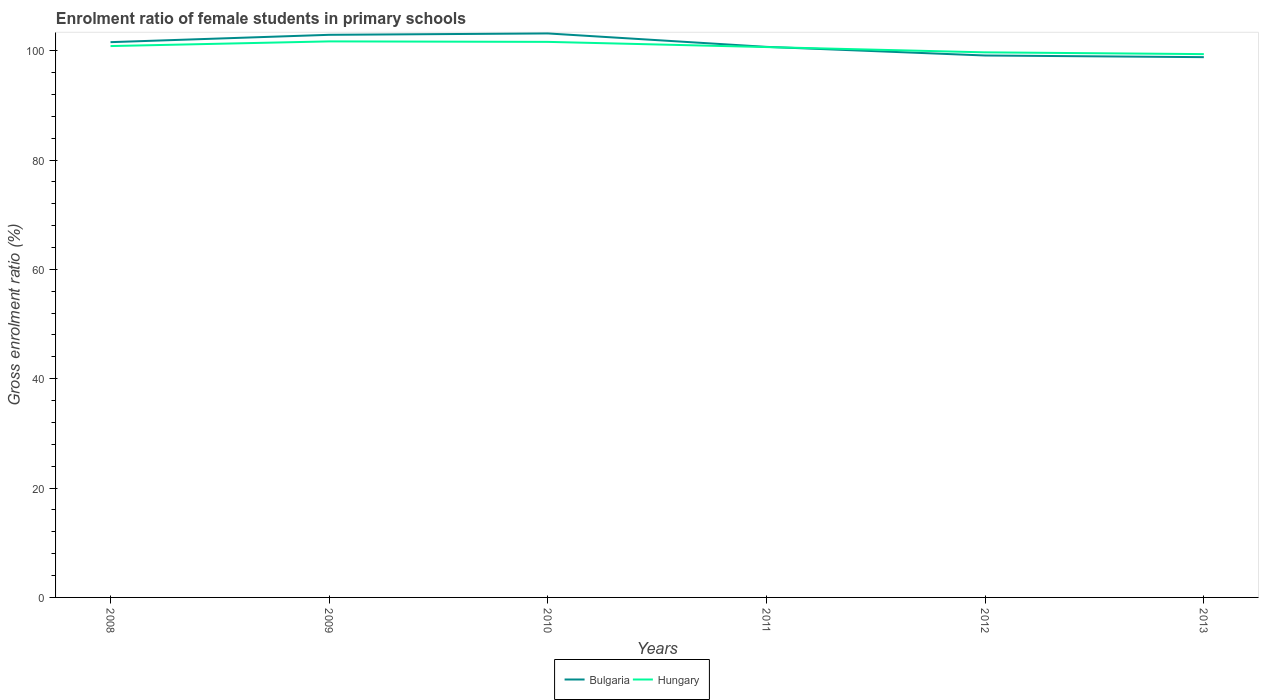Does the line corresponding to Hungary intersect with the line corresponding to Bulgaria?
Ensure brevity in your answer.  Yes. Across all years, what is the maximum enrolment ratio of female students in primary schools in Hungary?
Keep it short and to the point. 99.37. What is the total enrolment ratio of female students in primary schools in Bulgaria in the graph?
Make the answer very short. 2.44. What is the difference between the highest and the second highest enrolment ratio of female students in primary schools in Hungary?
Your answer should be compact. 2.33. What is the difference between the highest and the lowest enrolment ratio of female students in primary schools in Bulgaria?
Provide a short and direct response. 3. Is the enrolment ratio of female students in primary schools in Hungary strictly greater than the enrolment ratio of female students in primary schools in Bulgaria over the years?
Provide a short and direct response. No. How many years are there in the graph?
Give a very brief answer. 6. What is the difference between two consecutive major ticks on the Y-axis?
Make the answer very short. 20. Are the values on the major ticks of Y-axis written in scientific E-notation?
Give a very brief answer. No. What is the title of the graph?
Give a very brief answer. Enrolment ratio of female students in primary schools. Does "Kiribati" appear as one of the legend labels in the graph?
Your answer should be very brief. No. What is the label or title of the Y-axis?
Make the answer very short. Gross enrolment ratio (%). What is the Gross enrolment ratio (%) of Bulgaria in 2008?
Give a very brief answer. 101.55. What is the Gross enrolment ratio (%) of Hungary in 2008?
Provide a short and direct response. 100.84. What is the Gross enrolment ratio (%) of Bulgaria in 2009?
Keep it short and to the point. 102.9. What is the Gross enrolment ratio (%) of Hungary in 2009?
Give a very brief answer. 101.69. What is the Gross enrolment ratio (%) of Bulgaria in 2010?
Offer a terse response. 103.15. What is the Gross enrolment ratio (%) of Hungary in 2010?
Your answer should be very brief. 101.6. What is the Gross enrolment ratio (%) in Bulgaria in 2011?
Your response must be concise. 100.69. What is the Gross enrolment ratio (%) of Hungary in 2011?
Ensure brevity in your answer.  100.66. What is the Gross enrolment ratio (%) in Bulgaria in 2012?
Your response must be concise. 99.11. What is the Gross enrolment ratio (%) of Hungary in 2012?
Offer a terse response. 99.69. What is the Gross enrolment ratio (%) in Bulgaria in 2013?
Your answer should be compact. 98.81. What is the Gross enrolment ratio (%) of Hungary in 2013?
Provide a succinct answer. 99.37. Across all years, what is the maximum Gross enrolment ratio (%) in Bulgaria?
Give a very brief answer. 103.15. Across all years, what is the maximum Gross enrolment ratio (%) in Hungary?
Provide a succinct answer. 101.69. Across all years, what is the minimum Gross enrolment ratio (%) of Bulgaria?
Offer a terse response. 98.81. Across all years, what is the minimum Gross enrolment ratio (%) in Hungary?
Give a very brief answer. 99.37. What is the total Gross enrolment ratio (%) in Bulgaria in the graph?
Provide a succinct answer. 606.21. What is the total Gross enrolment ratio (%) of Hungary in the graph?
Make the answer very short. 603.84. What is the difference between the Gross enrolment ratio (%) of Bulgaria in 2008 and that in 2009?
Give a very brief answer. -1.34. What is the difference between the Gross enrolment ratio (%) in Hungary in 2008 and that in 2009?
Provide a short and direct response. -0.85. What is the difference between the Gross enrolment ratio (%) of Bulgaria in 2008 and that in 2010?
Offer a terse response. -1.59. What is the difference between the Gross enrolment ratio (%) of Hungary in 2008 and that in 2010?
Provide a succinct answer. -0.76. What is the difference between the Gross enrolment ratio (%) of Bulgaria in 2008 and that in 2011?
Ensure brevity in your answer.  0.86. What is the difference between the Gross enrolment ratio (%) in Hungary in 2008 and that in 2011?
Keep it short and to the point. 0.18. What is the difference between the Gross enrolment ratio (%) of Bulgaria in 2008 and that in 2012?
Your response must be concise. 2.44. What is the difference between the Gross enrolment ratio (%) of Hungary in 2008 and that in 2012?
Your answer should be very brief. 1.15. What is the difference between the Gross enrolment ratio (%) in Bulgaria in 2008 and that in 2013?
Offer a very short reply. 2.74. What is the difference between the Gross enrolment ratio (%) of Hungary in 2008 and that in 2013?
Keep it short and to the point. 1.47. What is the difference between the Gross enrolment ratio (%) in Bulgaria in 2009 and that in 2010?
Your answer should be very brief. -0.25. What is the difference between the Gross enrolment ratio (%) in Hungary in 2009 and that in 2010?
Offer a terse response. 0.09. What is the difference between the Gross enrolment ratio (%) of Bulgaria in 2009 and that in 2011?
Your answer should be compact. 2.2. What is the difference between the Gross enrolment ratio (%) in Hungary in 2009 and that in 2011?
Your answer should be compact. 1.04. What is the difference between the Gross enrolment ratio (%) of Bulgaria in 2009 and that in 2012?
Offer a very short reply. 3.78. What is the difference between the Gross enrolment ratio (%) of Hungary in 2009 and that in 2012?
Make the answer very short. 2. What is the difference between the Gross enrolment ratio (%) of Bulgaria in 2009 and that in 2013?
Offer a terse response. 4.08. What is the difference between the Gross enrolment ratio (%) in Hungary in 2009 and that in 2013?
Your response must be concise. 2.33. What is the difference between the Gross enrolment ratio (%) of Bulgaria in 2010 and that in 2011?
Provide a short and direct response. 2.46. What is the difference between the Gross enrolment ratio (%) of Hungary in 2010 and that in 2011?
Offer a very short reply. 0.95. What is the difference between the Gross enrolment ratio (%) in Bulgaria in 2010 and that in 2012?
Keep it short and to the point. 4.04. What is the difference between the Gross enrolment ratio (%) in Hungary in 2010 and that in 2012?
Provide a short and direct response. 1.92. What is the difference between the Gross enrolment ratio (%) of Bulgaria in 2010 and that in 2013?
Your answer should be very brief. 4.34. What is the difference between the Gross enrolment ratio (%) in Hungary in 2010 and that in 2013?
Make the answer very short. 2.24. What is the difference between the Gross enrolment ratio (%) in Bulgaria in 2011 and that in 2012?
Your response must be concise. 1.58. What is the difference between the Gross enrolment ratio (%) in Hungary in 2011 and that in 2012?
Provide a short and direct response. 0.97. What is the difference between the Gross enrolment ratio (%) in Bulgaria in 2011 and that in 2013?
Make the answer very short. 1.88. What is the difference between the Gross enrolment ratio (%) of Hungary in 2011 and that in 2013?
Your answer should be compact. 1.29. What is the difference between the Gross enrolment ratio (%) in Bulgaria in 2012 and that in 2013?
Keep it short and to the point. 0.3. What is the difference between the Gross enrolment ratio (%) in Hungary in 2012 and that in 2013?
Provide a succinct answer. 0.32. What is the difference between the Gross enrolment ratio (%) in Bulgaria in 2008 and the Gross enrolment ratio (%) in Hungary in 2009?
Provide a short and direct response. -0.14. What is the difference between the Gross enrolment ratio (%) in Bulgaria in 2008 and the Gross enrolment ratio (%) in Hungary in 2010?
Give a very brief answer. -0.05. What is the difference between the Gross enrolment ratio (%) of Bulgaria in 2008 and the Gross enrolment ratio (%) of Hungary in 2011?
Keep it short and to the point. 0.9. What is the difference between the Gross enrolment ratio (%) of Bulgaria in 2008 and the Gross enrolment ratio (%) of Hungary in 2012?
Offer a very short reply. 1.87. What is the difference between the Gross enrolment ratio (%) in Bulgaria in 2008 and the Gross enrolment ratio (%) in Hungary in 2013?
Ensure brevity in your answer.  2.19. What is the difference between the Gross enrolment ratio (%) of Bulgaria in 2009 and the Gross enrolment ratio (%) of Hungary in 2010?
Offer a terse response. 1.29. What is the difference between the Gross enrolment ratio (%) of Bulgaria in 2009 and the Gross enrolment ratio (%) of Hungary in 2011?
Make the answer very short. 2.24. What is the difference between the Gross enrolment ratio (%) in Bulgaria in 2009 and the Gross enrolment ratio (%) in Hungary in 2012?
Provide a succinct answer. 3.21. What is the difference between the Gross enrolment ratio (%) in Bulgaria in 2009 and the Gross enrolment ratio (%) in Hungary in 2013?
Your answer should be very brief. 3.53. What is the difference between the Gross enrolment ratio (%) of Bulgaria in 2010 and the Gross enrolment ratio (%) of Hungary in 2011?
Your answer should be very brief. 2.49. What is the difference between the Gross enrolment ratio (%) in Bulgaria in 2010 and the Gross enrolment ratio (%) in Hungary in 2012?
Your answer should be compact. 3.46. What is the difference between the Gross enrolment ratio (%) of Bulgaria in 2010 and the Gross enrolment ratio (%) of Hungary in 2013?
Your answer should be compact. 3.78. What is the difference between the Gross enrolment ratio (%) of Bulgaria in 2011 and the Gross enrolment ratio (%) of Hungary in 2013?
Offer a very short reply. 1.33. What is the difference between the Gross enrolment ratio (%) of Bulgaria in 2012 and the Gross enrolment ratio (%) of Hungary in 2013?
Ensure brevity in your answer.  -0.25. What is the average Gross enrolment ratio (%) of Bulgaria per year?
Give a very brief answer. 101.03. What is the average Gross enrolment ratio (%) of Hungary per year?
Your answer should be compact. 100.64. In the year 2008, what is the difference between the Gross enrolment ratio (%) of Bulgaria and Gross enrolment ratio (%) of Hungary?
Your answer should be compact. 0.71. In the year 2009, what is the difference between the Gross enrolment ratio (%) in Bulgaria and Gross enrolment ratio (%) in Hungary?
Your answer should be very brief. 1.2. In the year 2010, what is the difference between the Gross enrolment ratio (%) of Bulgaria and Gross enrolment ratio (%) of Hungary?
Give a very brief answer. 1.54. In the year 2011, what is the difference between the Gross enrolment ratio (%) in Bulgaria and Gross enrolment ratio (%) in Hungary?
Your response must be concise. 0.03. In the year 2012, what is the difference between the Gross enrolment ratio (%) of Bulgaria and Gross enrolment ratio (%) of Hungary?
Your response must be concise. -0.58. In the year 2013, what is the difference between the Gross enrolment ratio (%) in Bulgaria and Gross enrolment ratio (%) in Hungary?
Your response must be concise. -0.55. What is the ratio of the Gross enrolment ratio (%) of Hungary in 2008 to that in 2009?
Give a very brief answer. 0.99. What is the ratio of the Gross enrolment ratio (%) of Bulgaria in 2008 to that in 2010?
Your answer should be compact. 0.98. What is the ratio of the Gross enrolment ratio (%) of Hungary in 2008 to that in 2010?
Give a very brief answer. 0.99. What is the ratio of the Gross enrolment ratio (%) in Bulgaria in 2008 to that in 2011?
Provide a succinct answer. 1.01. What is the ratio of the Gross enrolment ratio (%) of Hungary in 2008 to that in 2011?
Your answer should be compact. 1. What is the ratio of the Gross enrolment ratio (%) of Bulgaria in 2008 to that in 2012?
Your response must be concise. 1.02. What is the ratio of the Gross enrolment ratio (%) in Hungary in 2008 to that in 2012?
Provide a succinct answer. 1.01. What is the ratio of the Gross enrolment ratio (%) in Bulgaria in 2008 to that in 2013?
Provide a succinct answer. 1.03. What is the ratio of the Gross enrolment ratio (%) in Hungary in 2008 to that in 2013?
Offer a very short reply. 1.01. What is the ratio of the Gross enrolment ratio (%) in Bulgaria in 2009 to that in 2011?
Keep it short and to the point. 1.02. What is the ratio of the Gross enrolment ratio (%) of Hungary in 2009 to that in 2011?
Give a very brief answer. 1.01. What is the ratio of the Gross enrolment ratio (%) in Bulgaria in 2009 to that in 2012?
Provide a short and direct response. 1.04. What is the ratio of the Gross enrolment ratio (%) in Hungary in 2009 to that in 2012?
Your answer should be very brief. 1.02. What is the ratio of the Gross enrolment ratio (%) in Bulgaria in 2009 to that in 2013?
Provide a succinct answer. 1.04. What is the ratio of the Gross enrolment ratio (%) of Hungary in 2009 to that in 2013?
Your response must be concise. 1.02. What is the ratio of the Gross enrolment ratio (%) of Bulgaria in 2010 to that in 2011?
Your answer should be compact. 1.02. What is the ratio of the Gross enrolment ratio (%) of Hungary in 2010 to that in 2011?
Your answer should be very brief. 1.01. What is the ratio of the Gross enrolment ratio (%) of Bulgaria in 2010 to that in 2012?
Ensure brevity in your answer.  1.04. What is the ratio of the Gross enrolment ratio (%) of Hungary in 2010 to that in 2012?
Ensure brevity in your answer.  1.02. What is the ratio of the Gross enrolment ratio (%) in Bulgaria in 2010 to that in 2013?
Offer a very short reply. 1.04. What is the ratio of the Gross enrolment ratio (%) of Hungary in 2010 to that in 2013?
Provide a short and direct response. 1.02. What is the ratio of the Gross enrolment ratio (%) of Bulgaria in 2011 to that in 2012?
Keep it short and to the point. 1.02. What is the ratio of the Gross enrolment ratio (%) in Hungary in 2011 to that in 2012?
Your answer should be very brief. 1.01. What is the ratio of the Gross enrolment ratio (%) in Bulgaria in 2011 to that in 2013?
Ensure brevity in your answer.  1.02. What is the difference between the highest and the second highest Gross enrolment ratio (%) in Bulgaria?
Your answer should be very brief. 0.25. What is the difference between the highest and the second highest Gross enrolment ratio (%) in Hungary?
Your response must be concise. 0.09. What is the difference between the highest and the lowest Gross enrolment ratio (%) of Bulgaria?
Your answer should be compact. 4.34. What is the difference between the highest and the lowest Gross enrolment ratio (%) of Hungary?
Your response must be concise. 2.33. 